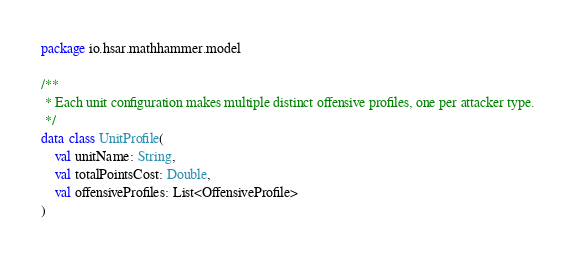Convert code to text. <code><loc_0><loc_0><loc_500><loc_500><_Kotlin_>package io.hsar.mathhammer.model

/**
 * Each unit configuration makes multiple distinct offensive profiles, one per attacker type.
 */
data class UnitProfile(
    val unitName: String,
    val totalPointsCost: Double,
    val offensiveProfiles: List<OffensiveProfile>
)</code> 